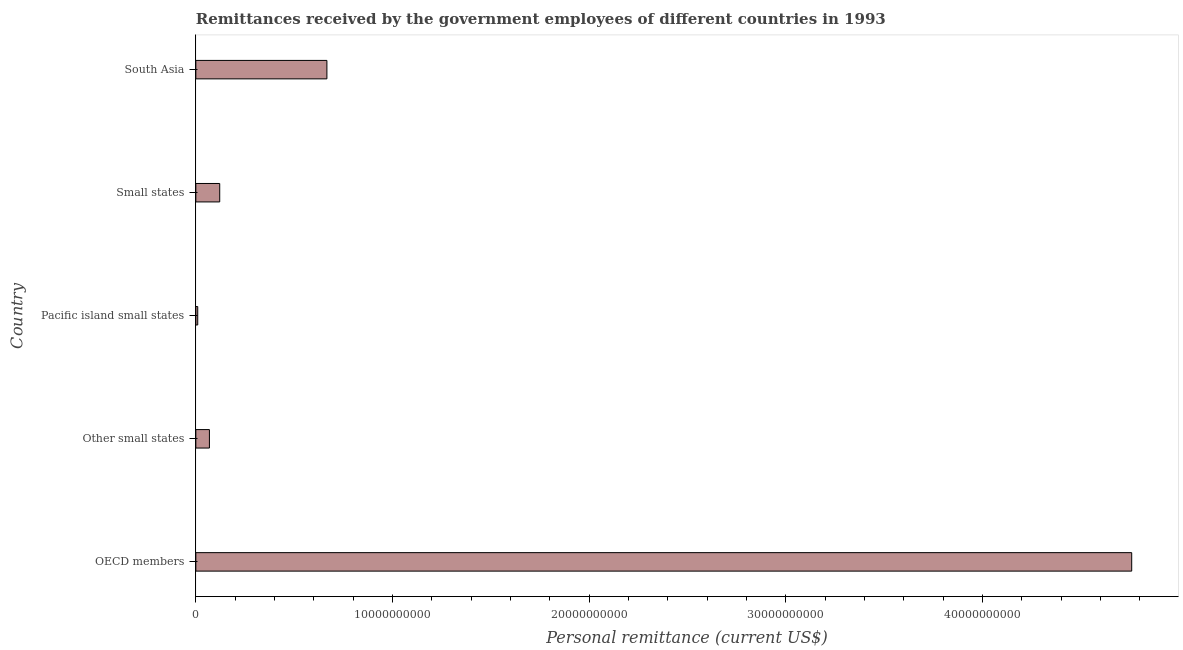Does the graph contain any zero values?
Provide a short and direct response. No. Does the graph contain grids?
Provide a succinct answer. No. What is the title of the graph?
Your answer should be very brief. Remittances received by the government employees of different countries in 1993. What is the label or title of the X-axis?
Provide a succinct answer. Personal remittance (current US$). What is the label or title of the Y-axis?
Give a very brief answer. Country. What is the personal remittances in South Asia?
Keep it short and to the point. 6.66e+09. Across all countries, what is the maximum personal remittances?
Offer a terse response. 4.76e+1. Across all countries, what is the minimum personal remittances?
Your response must be concise. 9.72e+07. In which country was the personal remittances minimum?
Your answer should be compact. Pacific island small states. What is the sum of the personal remittances?
Your answer should be compact. 5.63e+1. What is the difference between the personal remittances in OECD members and Pacific island small states?
Ensure brevity in your answer.  4.75e+1. What is the average personal remittances per country?
Give a very brief answer. 1.13e+1. What is the median personal remittances?
Your answer should be compact. 1.22e+09. In how many countries, is the personal remittances greater than 32000000000 US$?
Offer a very short reply. 1. What is the ratio of the personal remittances in OECD members to that in Other small states?
Your answer should be compact. 68.88. Is the difference between the personal remittances in Other small states and Pacific island small states greater than the difference between any two countries?
Make the answer very short. No. What is the difference between the highest and the second highest personal remittances?
Offer a very short reply. 4.09e+1. Is the sum of the personal remittances in Other small states and Small states greater than the maximum personal remittances across all countries?
Provide a succinct answer. No. What is the difference between the highest and the lowest personal remittances?
Ensure brevity in your answer.  4.75e+1. In how many countries, is the personal remittances greater than the average personal remittances taken over all countries?
Provide a succinct answer. 1. Are all the bars in the graph horizontal?
Your answer should be very brief. Yes. What is the difference between two consecutive major ticks on the X-axis?
Keep it short and to the point. 1.00e+1. Are the values on the major ticks of X-axis written in scientific E-notation?
Provide a short and direct response. No. What is the Personal remittance (current US$) of OECD members?
Offer a terse response. 4.76e+1. What is the Personal remittance (current US$) of Other small states?
Your answer should be very brief. 6.91e+08. What is the Personal remittance (current US$) of Pacific island small states?
Your answer should be compact. 9.72e+07. What is the Personal remittance (current US$) in Small states?
Ensure brevity in your answer.  1.22e+09. What is the Personal remittance (current US$) of South Asia?
Your response must be concise. 6.66e+09. What is the difference between the Personal remittance (current US$) in OECD members and Other small states?
Your response must be concise. 4.69e+1. What is the difference between the Personal remittance (current US$) in OECD members and Pacific island small states?
Keep it short and to the point. 4.75e+1. What is the difference between the Personal remittance (current US$) in OECD members and Small states?
Provide a short and direct response. 4.64e+1. What is the difference between the Personal remittance (current US$) in OECD members and South Asia?
Keep it short and to the point. 4.09e+1. What is the difference between the Personal remittance (current US$) in Other small states and Pacific island small states?
Give a very brief answer. 5.94e+08. What is the difference between the Personal remittance (current US$) in Other small states and Small states?
Keep it short and to the point. -5.24e+08. What is the difference between the Personal remittance (current US$) in Other small states and South Asia?
Offer a very short reply. -5.97e+09. What is the difference between the Personal remittance (current US$) in Pacific island small states and Small states?
Give a very brief answer. -1.12e+09. What is the difference between the Personal remittance (current US$) in Pacific island small states and South Asia?
Provide a short and direct response. -6.57e+09. What is the difference between the Personal remittance (current US$) in Small states and South Asia?
Your response must be concise. -5.45e+09. What is the ratio of the Personal remittance (current US$) in OECD members to that in Other small states?
Your answer should be very brief. 68.88. What is the ratio of the Personal remittance (current US$) in OECD members to that in Pacific island small states?
Give a very brief answer. 489.35. What is the ratio of the Personal remittance (current US$) in OECD members to that in Small states?
Offer a terse response. 39.16. What is the ratio of the Personal remittance (current US$) in OECD members to that in South Asia?
Your response must be concise. 7.14. What is the ratio of the Personal remittance (current US$) in Other small states to that in Pacific island small states?
Offer a very short reply. 7.11. What is the ratio of the Personal remittance (current US$) in Other small states to that in Small states?
Offer a terse response. 0.57. What is the ratio of the Personal remittance (current US$) in Other small states to that in South Asia?
Provide a succinct answer. 0.1. What is the ratio of the Personal remittance (current US$) in Pacific island small states to that in Small states?
Provide a short and direct response. 0.08. What is the ratio of the Personal remittance (current US$) in Pacific island small states to that in South Asia?
Give a very brief answer. 0.01. What is the ratio of the Personal remittance (current US$) in Small states to that in South Asia?
Your answer should be compact. 0.18. 